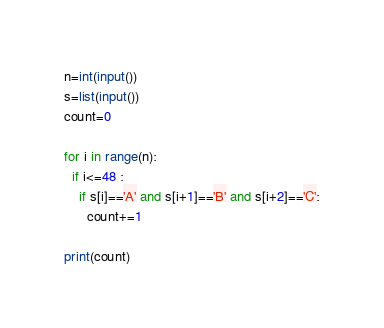<code> <loc_0><loc_0><loc_500><loc_500><_Python_>n=int(input())
s=list(input())
count=0

for i in range(n):
  if i<=48 :
    if s[i]=='A' and s[i+1]=='B' and s[i+2]=='C':
      count+=1
    
print(count)
</code> 